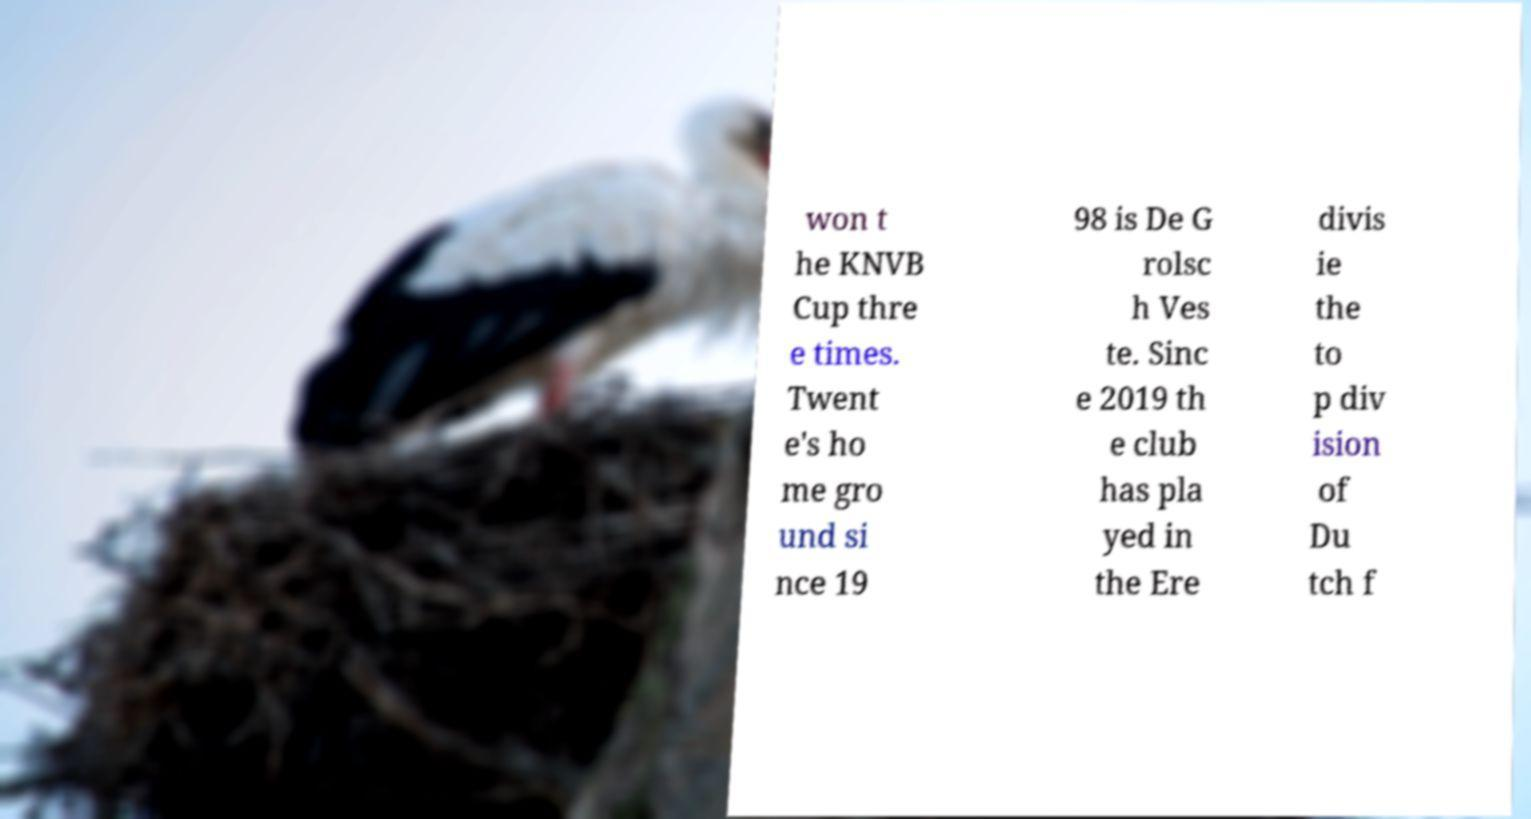Please read and relay the text visible in this image. What does it say? won t he KNVB Cup thre e times. Twent e's ho me gro und si nce 19 98 is De G rolsc h Ves te. Sinc e 2019 th e club has pla yed in the Ere divis ie the to p div ision of Du tch f 